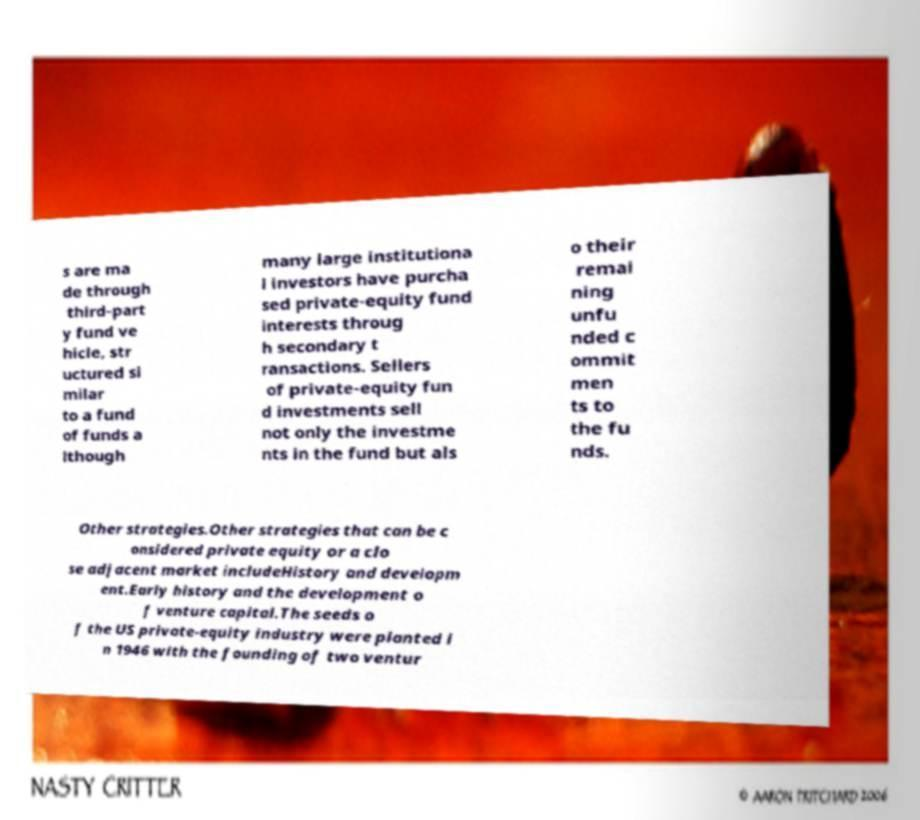Can you accurately transcribe the text from the provided image for me? s are ma de through third-part y fund ve hicle, str uctured si milar to a fund of funds a lthough many large institutiona l investors have purcha sed private-equity fund interests throug h secondary t ransactions. Sellers of private-equity fun d investments sell not only the investme nts in the fund but als o their remai ning unfu nded c ommit men ts to the fu nds. Other strategies.Other strategies that can be c onsidered private equity or a clo se adjacent market includeHistory and developm ent.Early history and the development o f venture capital.The seeds o f the US private-equity industry were planted i n 1946 with the founding of two ventur 